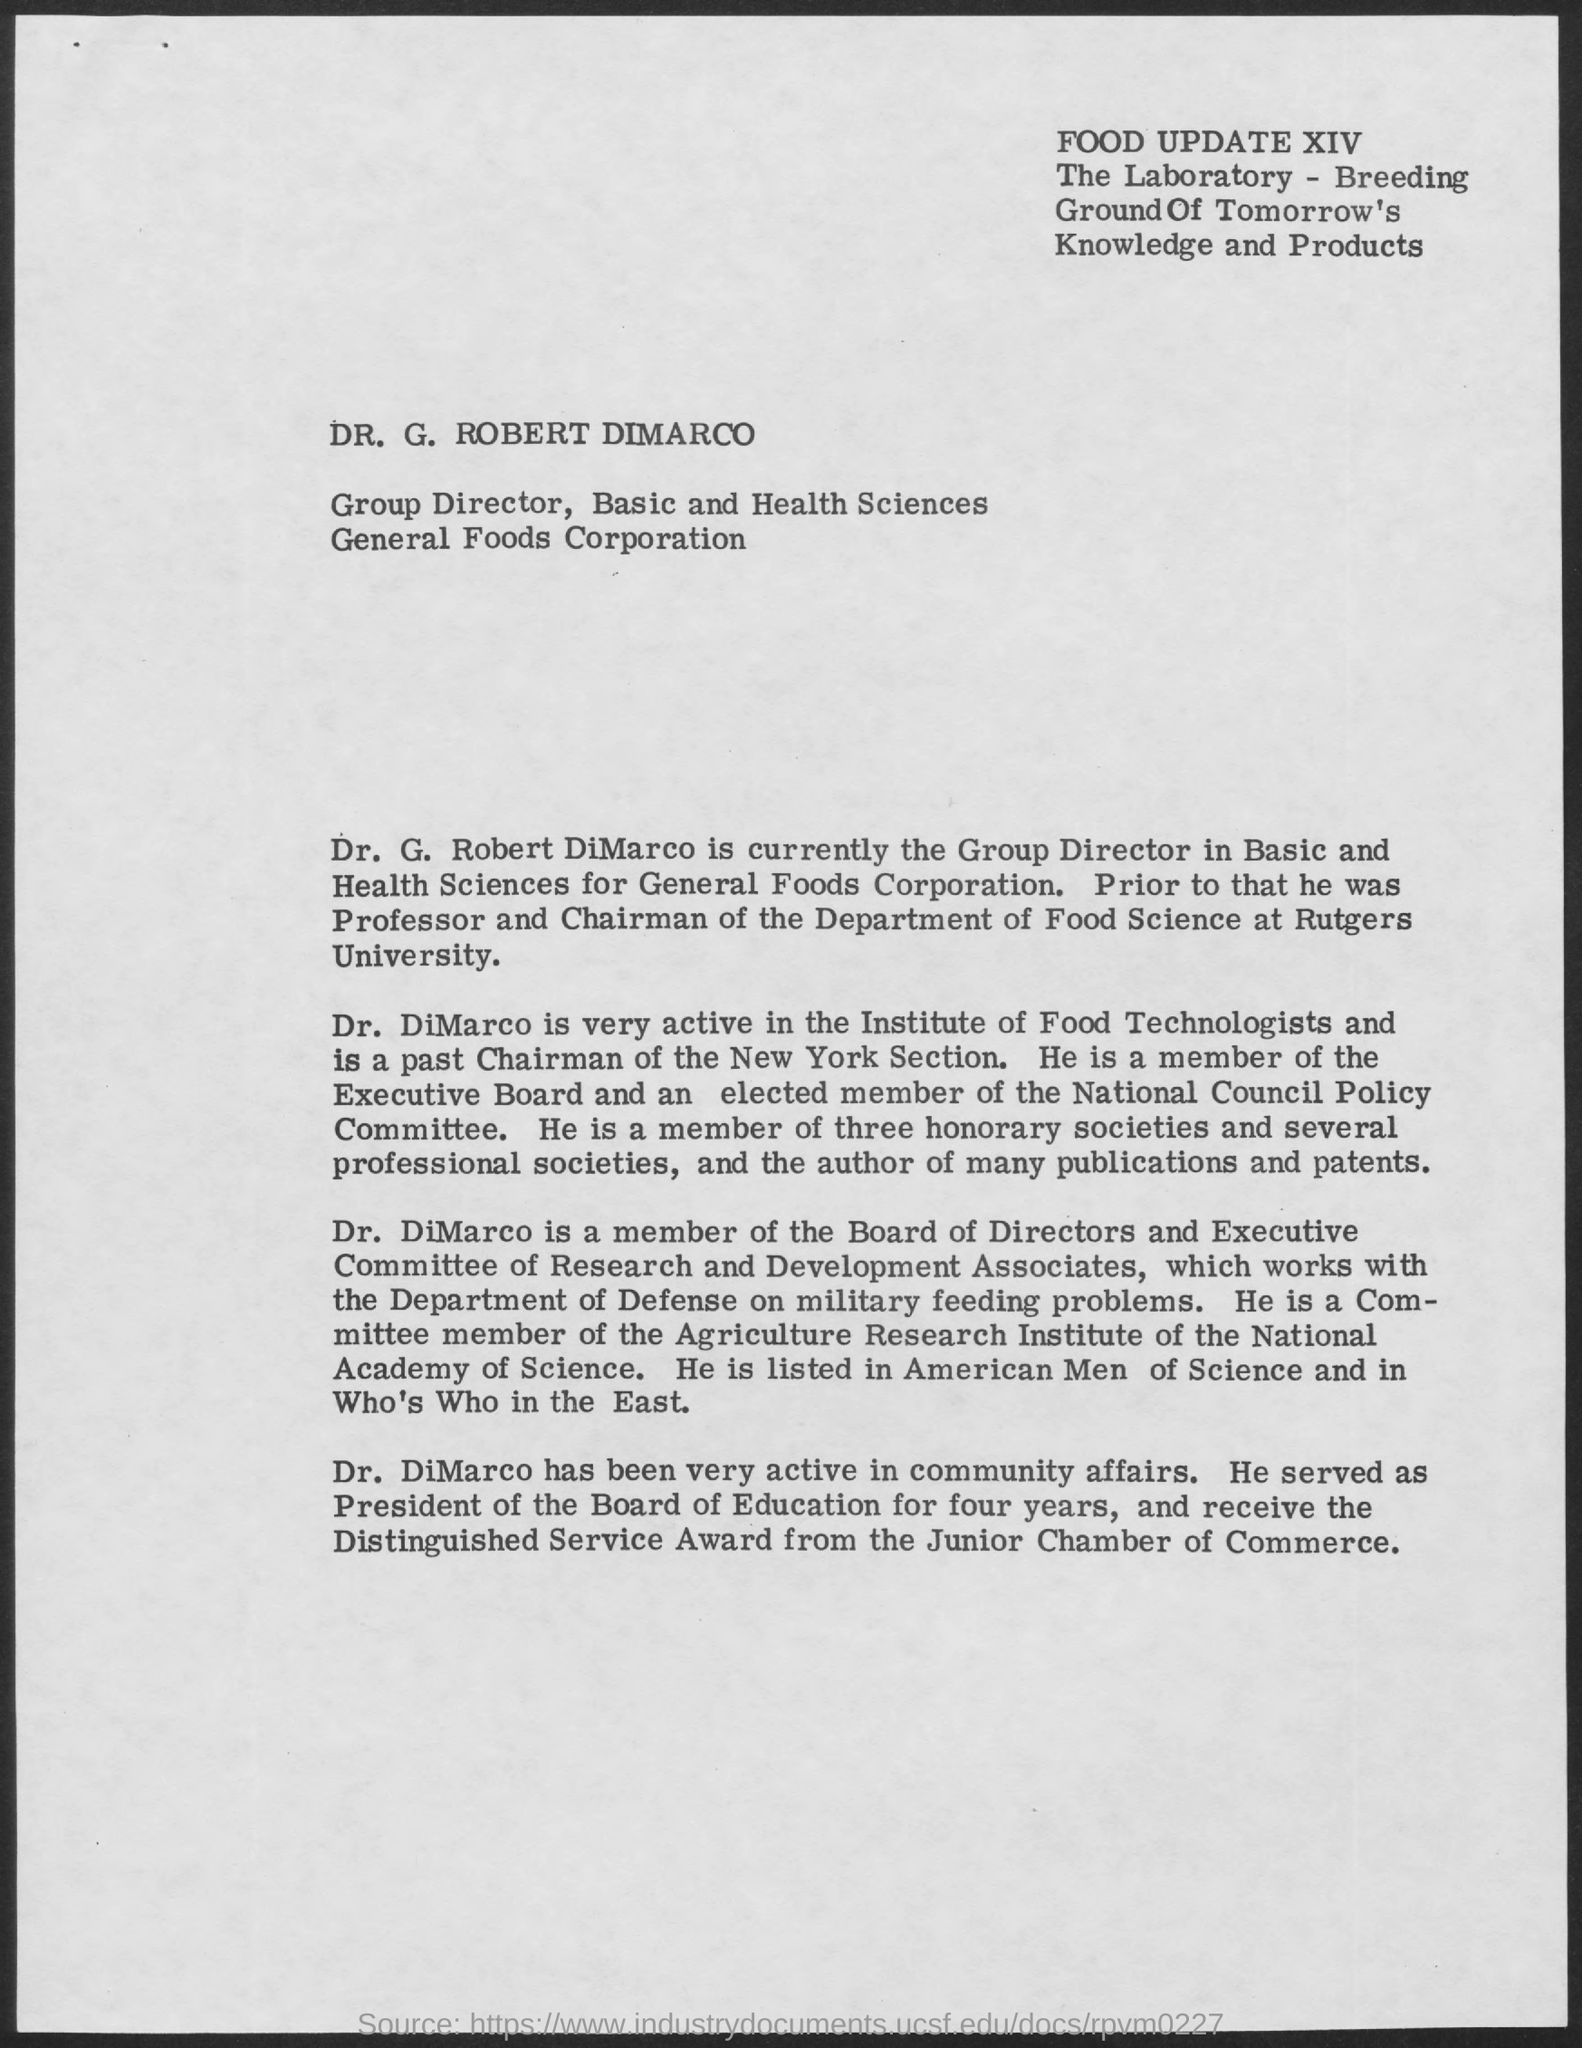Who is the Group Director
Your answer should be very brief. Dr. Dimarco. Which Award was received by Dr. DiMarco
Your answer should be compact. The Distinguished Service Award. From Where the award was given to Dr. DiMarco
Your answer should be compact. Junior Chamber of Commerce. 